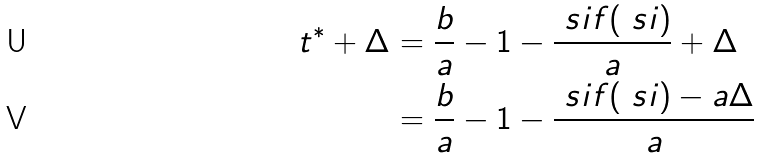Convert formula to latex. <formula><loc_0><loc_0><loc_500><loc_500>t ^ { * } + \Delta & = \frac { b } { a } - 1 - \frac { \ s i f ( \ s i ) } { a } + \Delta \\ & = \frac { b } { a } - 1 - \frac { \ s i f ( \ s i ) - a \Delta } { a }</formula> 